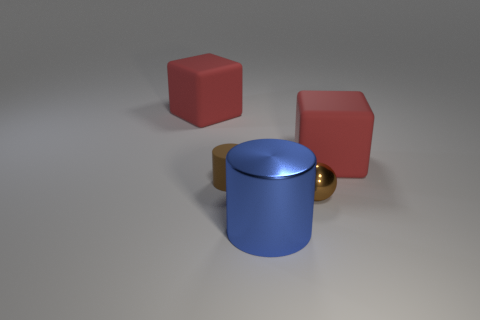Add 1 small brown shiny balls. How many objects exist? 6 Subtract all cylinders. How many objects are left? 3 Add 4 cyan balls. How many cyan balls exist? 4 Subtract 0 red balls. How many objects are left? 5 Subtract 2 blocks. How many blocks are left? 0 Subtract all cyan cubes. Subtract all blue spheres. How many cubes are left? 2 Subtract all brown balls. How many blue cylinders are left? 1 Subtract all big blocks. Subtract all small brown matte things. How many objects are left? 2 Add 5 red cubes. How many red cubes are left? 7 